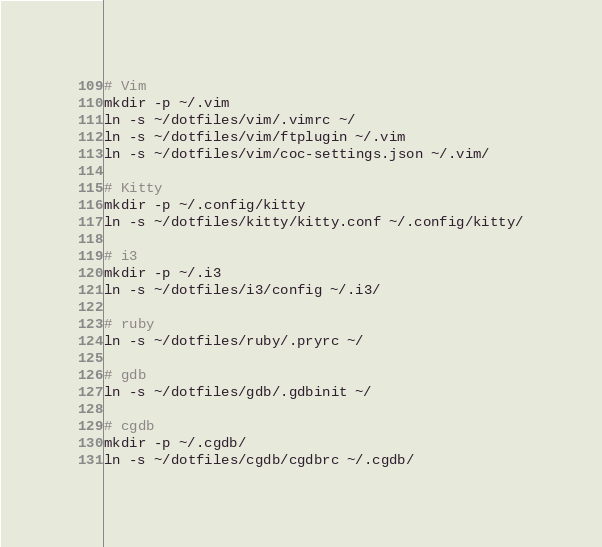Convert code to text. <code><loc_0><loc_0><loc_500><loc_500><_Bash_># Vim
mkdir -p ~/.vim
ln -s ~/dotfiles/vim/.vimrc ~/
ln -s ~/dotfiles/vim/ftplugin ~/.vim
ln -s ~/dotfiles/vim/coc-settings.json ~/.vim/

# Kitty
mkdir -p ~/.config/kitty
ln -s ~/dotfiles/kitty/kitty.conf ~/.config/kitty/

# i3
mkdir -p ~/.i3
ln -s ~/dotfiles/i3/config ~/.i3/

# ruby
ln -s ~/dotfiles/ruby/.pryrc ~/

# gdb
ln -s ~/dotfiles/gdb/.gdbinit ~/

# cgdb
mkdir -p ~/.cgdb/
ln -s ~/dotfiles/cgdb/cgdbrc ~/.cgdb/
</code> 